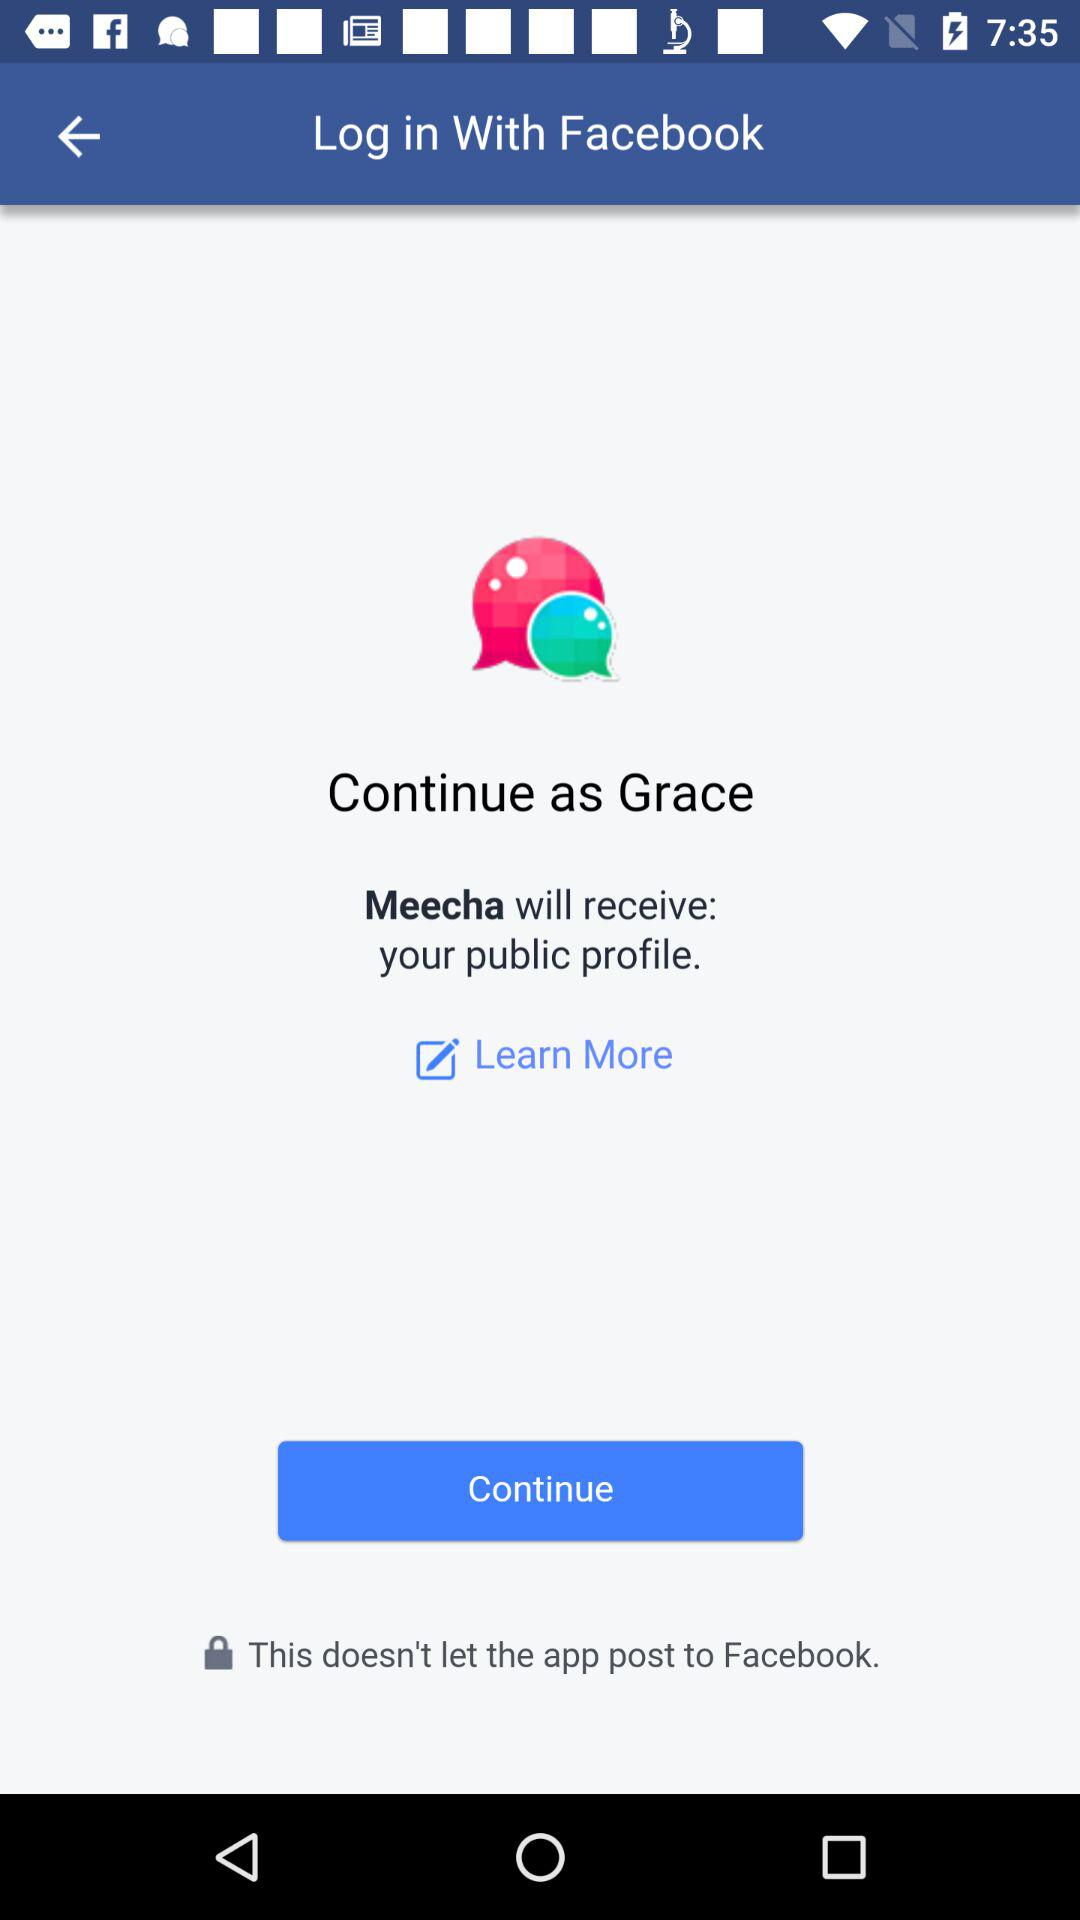What information will Meecha receive? Meecha will receive your public profile. 